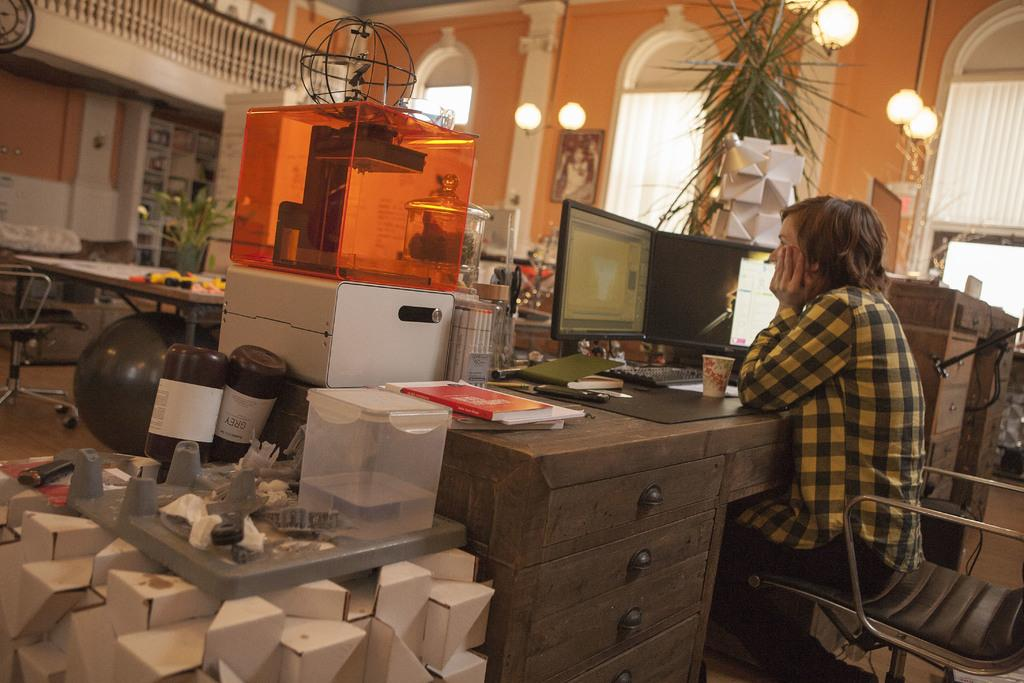What is the person in the image doing? The person is sitting on a chair and looking at a system. What is placed in front of the person? There is a glass in front of the person. What other objects can be seen in the image? There is a plant and an air balloon in the image. What type of songs can be heard coming from the vase in the image? There is no vase present in the image, and therefore no songs can be heard from it. 